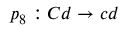<formula> <loc_0><loc_0><loc_500><loc_500>p _ { 8 } \colon C d \rightarrow c d</formula> 